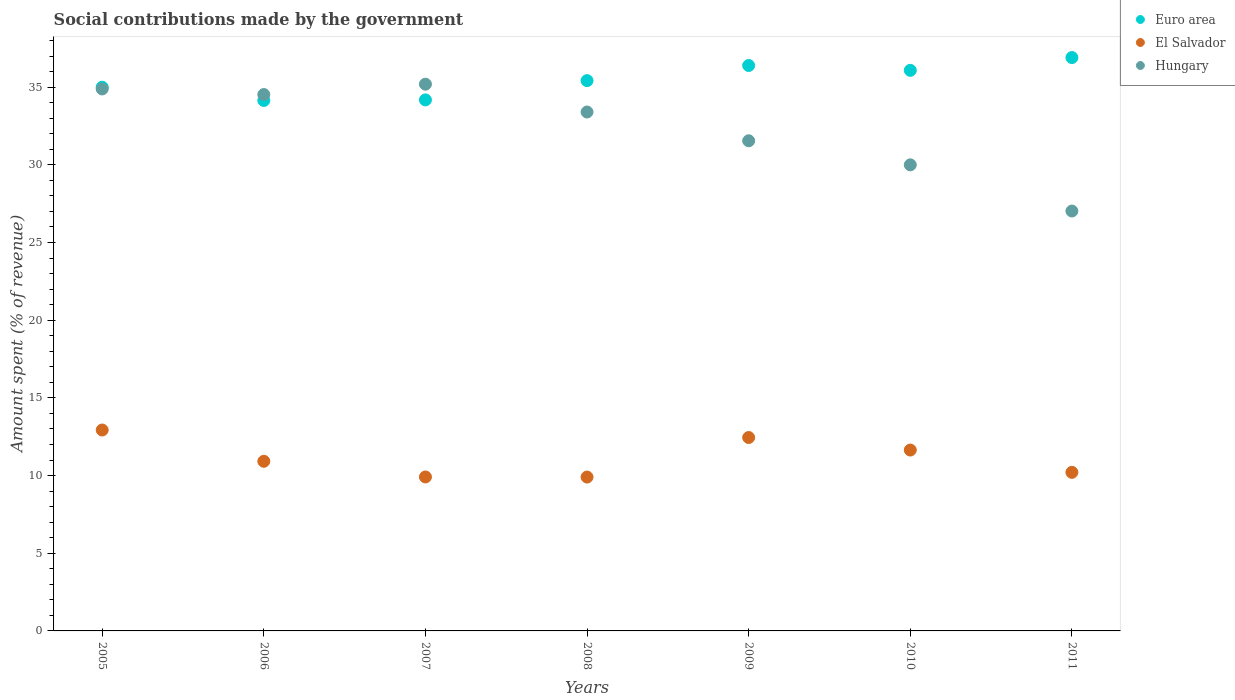What is the amount spent (in %) on social contributions in Hungary in 2007?
Ensure brevity in your answer.  35.19. Across all years, what is the maximum amount spent (in %) on social contributions in Hungary?
Offer a terse response. 35.19. Across all years, what is the minimum amount spent (in %) on social contributions in Hungary?
Ensure brevity in your answer.  27.03. In which year was the amount spent (in %) on social contributions in Euro area minimum?
Give a very brief answer. 2006. What is the total amount spent (in %) on social contributions in El Salvador in the graph?
Your answer should be compact. 77.96. What is the difference between the amount spent (in %) on social contributions in Hungary in 2008 and that in 2009?
Offer a terse response. 1.85. What is the difference between the amount spent (in %) on social contributions in El Salvador in 2005 and the amount spent (in %) on social contributions in Euro area in 2007?
Provide a short and direct response. -21.25. What is the average amount spent (in %) on social contributions in Euro area per year?
Ensure brevity in your answer.  35.44. In the year 2007, what is the difference between the amount spent (in %) on social contributions in Hungary and amount spent (in %) on social contributions in El Salvador?
Offer a very short reply. 25.28. In how many years, is the amount spent (in %) on social contributions in Hungary greater than 34 %?
Ensure brevity in your answer.  3. What is the ratio of the amount spent (in %) on social contributions in Euro area in 2007 to that in 2009?
Your answer should be compact. 0.94. Is the amount spent (in %) on social contributions in Euro area in 2005 less than that in 2006?
Give a very brief answer. No. Is the difference between the amount spent (in %) on social contributions in Hungary in 2007 and 2011 greater than the difference between the amount spent (in %) on social contributions in El Salvador in 2007 and 2011?
Offer a very short reply. Yes. What is the difference between the highest and the second highest amount spent (in %) on social contributions in El Salvador?
Offer a very short reply. 0.48. What is the difference between the highest and the lowest amount spent (in %) on social contributions in Hungary?
Provide a succinct answer. 8.16. In how many years, is the amount spent (in %) on social contributions in Euro area greater than the average amount spent (in %) on social contributions in Euro area taken over all years?
Offer a terse response. 3. Is the amount spent (in %) on social contributions in Euro area strictly less than the amount spent (in %) on social contributions in El Salvador over the years?
Make the answer very short. No. Are the values on the major ticks of Y-axis written in scientific E-notation?
Keep it short and to the point. No. Does the graph contain any zero values?
Provide a short and direct response. No. How many legend labels are there?
Provide a succinct answer. 3. What is the title of the graph?
Give a very brief answer. Social contributions made by the government. What is the label or title of the Y-axis?
Keep it short and to the point. Amount spent (% of revenue). What is the Amount spent (% of revenue) in Euro area in 2005?
Provide a short and direct response. 35. What is the Amount spent (% of revenue) of El Salvador in 2005?
Give a very brief answer. 12.93. What is the Amount spent (% of revenue) of Hungary in 2005?
Keep it short and to the point. 34.88. What is the Amount spent (% of revenue) in Euro area in 2006?
Provide a succinct answer. 34.14. What is the Amount spent (% of revenue) of El Salvador in 2006?
Provide a succinct answer. 10.92. What is the Amount spent (% of revenue) of Hungary in 2006?
Your response must be concise. 34.52. What is the Amount spent (% of revenue) in Euro area in 2007?
Your answer should be very brief. 34.18. What is the Amount spent (% of revenue) of El Salvador in 2007?
Your answer should be compact. 9.91. What is the Amount spent (% of revenue) in Hungary in 2007?
Provide a short and direct response. 35.19. What is the Amount spent (% of revenue) in Euro area in 2008?
Provide a succinct answer. 35.42. What is the Amount spent (% of revenue) in El Salvador in 2008?
Provide a succinct answer. 9.9. What is the Amount spent (% of revenue) of Hungary in 2008?
Provide a short and direct response. 33.4. What is the Amount spent (% of revenue) in Euro area in 2009?
Offer a terse response. 36.39. What is the Amount spent (% of revenue) of El Salvador in 2009?
Your answer should be very brief. 12.45. What is the Amount spent (% of revenue) of Hungary in 2009?
Provide a succinct answer. 31.55. What is the Amount spent (% of revenue) in Euro area in 2010?
Keep it short and to the point. 36.08. What is the Amount spent (% of revenue) of El Salvador in 2010?
Your answer should be very brief. 11.64. What is the Amount spent (% of revenue) of Hungary in 2010?
Provide a succinct answer. 30. What is the Amount spent (% of revenue) in Euro area in 2011?
Provide a short and direct response. 36.9. What is the Amount spent (% of revenue) in El Salvador in 2011?
Your answer should be compact. 10.21. What is the Amount spent (% of revenue) of Hungary in 2011?
Your answer should be compact. 27.03. Across all years, what is the maximum Amount spent (% of revenue) of Euro area?
Make the answer very short. 36.9. Across all years, what is the maximum Amount spent (% of revenue) of El Salvador?
Keep it short and to the point. 12.93. Across all years, what is the maximum Amount spent (% of revenue) in Hungary?
Keep it short and to the point. 35.19. Across all years, what is the minimum Amount spent (% of revenue) in Euro area?
Give a very brief answer. 34.14. Across all years, what is the minimum Amount spent (% of revenue) in El Salvador?
Ensure brevity in your answer.  9.9. Across all years, what is the minimum Amount spent (% of revenue) in Hungary?
Provide a succinct answer. 27.03. What is the total Amount spent (% of revenue) of Euro area in the graph?
Your answer should be very brief. 248.11. What is the total Amount spent (% of revenue) in El Salvador in the graph?
Make the answer very short. 77.96. What is the total Amount spent (% of revenue) of Hungary in the graph?
Your answer should be compact. 226.57. What is the difference between the Amount spent (% of revenue) of Euro area in 2005 and that in 2006?
Provide a short and direct response. 0.85. What is the difference between the Amount spent (% of revenue) of El Salvador in 2005 and that in 2006?
Offer a terse response. 2.01. What is the difference between the Amount spent (% of revenue) in Hungary in 2005 and that in 2006?
Give a very brief answer. 0.36. What is the difference between the Amount spent (% of revenue) in Euro area in 2005 and that in 2007?
Offer a very short reply. 0.82. What is the difference between the Amount spent (% of revenue) in El Salvador in 2005 and that in 2007?
Your response must be concise. 3.02. What is the difference between the Amount spent (% of revenue) of Hungary in 2005 and that in 2007?
Make the answer very short. -0.31. What is the difference between the Amount spent (% of revenue) in Euro area in 2005 and that in 2008?
Your answer should be very brief. -0.42. What is the difference between the Amount spent (% of revenue) of El Salvador in 2005 and that in 2008?
Provide a succinct answer. 3.03. What is the difference between the Amount spent (% of revenue) in Hungary in 2005 and that in 2008?
Offer a terse response. 1.48. What is the difference between the Amount spent (% of revenue) of Euro area in 2005 and that in 2009?
Provide a succinct answer. -1.4. What is the difference between the Amount spent (% of revenue) of El Salvador in 2005 and that in 2009?
Keep it short and to the point. 0.48. What is the difference between the Amount spent (% of revenue) in Hungary in 2005 and that in 2009?
Your response must be concise. 3.34. What is the difference between the Amount spent (% of revenue) of Euro area in 2005 and that in 2010?
Offer a very short reply. -1.08. What is the difference between the Amount spent (% of revenue) in El Salvador in 2005 and that in 2010?
Ensure brevity in your answer.  1.29. What is the difference between the Amount spent (% of revenue) of Hungary in 2005 and that in 2010?
Give a very brief answer. 4.89. What is the difference between the Amount spent (% of revenue) of Euro area in 2005 and that in 2011?
Your answer should be compact. -1.91. What is the difference between the Amount spent (% of revenue) in El Salvador in 2005 and that in 2011?
Provide a succinct answer. 2.73. What is the difference between the Amount spent (% of revenue) in Hungary in 2005 and that in 2011?
Offer a very short reply. 7.86. What is the difference between the Amount spent (% of revenue) in Euro area in 2006 and that in 2007?
Ensure brevity in your answer.  -0.04. What is the difference between the Amount spent (% of revenue) of El Salvador in 2006 and that in 2007?
Keep it short and to the point. 1.01. What is the difference between the Amount spent (% of revenue) in Hungary in 2006 and that in 2007?
Make the answer very short. -0.67. What is the difference between the Amount spent (% of revenue) in Euro area in 2006 and that in 2008?
Make the answer very short. -1.28. What is the difference between the Amount spent (% of revenue) in El Salvador in 2006 and that in 2008?
Provide a short and direct response. 1.02. What is the difference between the Amount spent (% of revenue) of Hungary in 2006 and that in 2008?
Your answer should be very brief. 1.12. What is the difference between the Amount spent (% of revenue) of Euro area in 2006 and that in 2009?
Make the answer very short. -2.25. What is the difference between the Amount spent (% of revenue) in El Salvador in 2006 and that in 2009?
Your response must be concise. -1.53. What is the difference between the Amount spent (% of revenue) in Hungary in 2006 and that in 2009?
Provide a short and direct response. 2.98. What is the difference between the Amount spent (% of revenue) of Euro area in 2006 and that in 2010?
Make the answer very short. -1.94. What is the difference between the Amount spent (% of revenue) in El Salvador in 2006 and that in 2010?
Ensure brevity in your answer.  -0.72. What is the difference between the Amount spent (% of revenue) in Hungary in 2006 and that in 2010?
Offer a very short reply. 4.52. What is the difference between the Amount spent (% of revenue) of Euro area in 2006 and that in 2011?
Your answer should be very brief. -2.76. What is the difference between the Amount spent (% of revenue) in El Salvador in 2006 and that in 2011?
Provide a succinct answer. 0.71. What is the difference between the Amount spent (% of revenue) of Hungary in 2006 and that in 2011?
Give a very brief answer. 7.5. What is the difference between the Amount spent (% of revenue) of Euro area in 2007 and that in 2008?
Keep it short and to the point. -1.24. What is the difference between the Amount spent (% of revenue) of El Salvador in 2007 and that in 2008?
Keep it short and to the point. 0.01. What is the difference between the Amount spent (% of revenue) of Hungary in 2007 and that in 2008?
Ensure brevity in your answer.  1.79. What is the difference between the Amount spent (% of revenue) of Euro area in 2007 and that in 2009?
Provide a short and direct response. -2.21. What is the difference between the Amount spent (% of revenue) in El Salvador in 2007 and that in 2009?
Offer a terse response. -2.54. What is the difference between the Amount spent (% of revenue) in Hungary in 2007 and that in 2009?
Your answer should be very brief. 3.64. What is the difference between the Amount spent (% of revenue) of Euro area in 2007 and that in 2010?
Your answer should be compact. -1.9. What is the difference between the Amount spent (% of revenue) of El Salvador in 2007 and that in 2010?
Keep it short and to the point. -1.73. What is the difference between the Amount spent (% of revenue) in Hungary in 2007 and that in 2010?
Give a very brief answer. 5.19. What is the difference between the Amount spent (% of revenue) of Euro area in 2007 and that in 2011?
Offer a terse response. -2.73. What is the difference between the Amount spent (% of revenue) in El Salvador in 2007 and that in 2011?
Provide a short and direct response. -0.3. What is the difference between the Amount spent (% of revenue) in Hungary in 2007 and that in 2011?
Make the answer very short. 8.16. What is the difference between the Amount spent (% of revenue) of Euro area in 2008 and that in 2009?
Make the answer very short. -0.97. What is the difference between the Amount spent (% of revenue) in El Salvador in 2008 and that in 2009?
Offer a very short reply. -2.54. What is the difference between the Amount spent (% of revenue) in Hungary in 2008 and that in 2009?
Offer a terse response. 1.85. What is the difference between the Amount spent (% of revenue) of Euro area in 2008 and that in 2010?
Offer a very short reply. -0.66. What is the difference between the Amount spent (% of revenue) in El Salvador in 2008 and that in 2010?
Give a very brief answer. -1.74. What is the difference between the Amount spent (% of revenue) in Hungary in 2008 and that in 2010?
Offer a very short reply. 3.4. What is the difference between the Amount spent (% of revenue) in Euro area in 2008 and that in 2011?
Your answer should be very brief. -1.48. What is the difference between the Amount spent (% of revenue) in El Salvador in 2008 and that in 2011?
Your answer should be compact. -0.3. What is the difference between the Amount spent (% of revenue) of Hungary in 2008 and that in 2011?
Ensure brevity in your answer.  6.37. What is the difference between the Amount spent (% of revenue) of Euro area in 2009 and that in 2010?
Your answer should be very brief. 0.31. What is the difference between the Amount spent (% of revenue) of El Salvador in 2009 and that in 2010?
Make the answer very short. 0.81. What is the difference between the Amount spent (% of revenue) of Hungary in 2009 and that in 2010?
Make the answer very short. 1.55. What is the difference between the Amount spent (% of revenue) of Euro area in 2009 and that in 2011?
Ensure brevity in your answer.  -0.51. What is the difference between the Amount spent (% of revenue) of El Salvador in 2009 and that in 2011?
Your response must be concise. 2.24. What is the difference between the Amount spent (% of revenue) of Hungary in 2009 and that in 2011?
Ensure brevity in your answer.  4.52. What is the difference between the Amount spent (% of revenue) in Euro area in 2010 and that in 2011?
Ensure brevity in your answer.  -0.82. What is the difference between the Amount spent (% of revenue) of El Salvador in 2010 and that in 2011?
Offer a very short reply. 1.44. What is the difference between the Amount spent (% of revenue) of Hungary in 2010 and that in 2011?
Keep it short and to the point. 2.97. What is the difference between the Amount spent (% of revenue) of Euro area in 2005 and the Amount spent (% of revenue) of El Salvador in 2006?
Give a very brief answer. 24.08. What is the difference between the Amount spent (% of revenue) in Euro area in 2005 and the Amount spent (% of revenue) in Hungary in 2006?
Offer a terse response. 0.47. What is the difference between the Amount spent (% of revenue) in El Salvador in 2005 and the Amount spent (% of revenue) in Hungary in 2006?
Make the answer very short. -21.59. What is the difference between the Amount spent (% of revenue) in Euro area in 2005 and the Amount spent (% of revenue) in El Salvador in 2007?
Your answer should be very brief. 25.09. What is the difference between the Amount spent (% of revenue) in Euro area in 2005 and the Amount spent (% of revenue) in Hungary in 2007?
Offer a terse response. -0.19. What is the difference between the Amount spent (% of revenue) of El Salvador in 2005 and the Amount spent (% of revenue) of Hungary in 2007?
Offer a terse response. -22.26. What is the difference between the Amount spent (% of revenue) in Euro area in 2005 and the Amount spent (% of revenue) in El Salvador in 2008?
Offer a very short reply. 25.09. What is the difference between the Amount spent (% of revenue) of Euro area in 2005 and the Amount spent (% of revenue) of Hungary in 2008?
Provide a succinct answer. 1.6. What is the difference between the Amount spent (% of revenue) of El Salvador in 2005 and the Amount spent (% of revenue) of Hungary in 2008?
Provide a succinct answer. -20.47. What is the difference between the Amount spent (% of revenue) of Euro area in 2005 and the Amount spent (% of revenue) of El Salvador in 2009?
Keep it short and to the point. 22.55. What is the difference between the Amount spent (% of revenue) of Euro area in 2005 and the Amount spent (% of revenue) of Hungary in 2009?
Offer a very short reply. 3.45. What is the difference between the Amount spent (% of revenue) in El Salvador in 2005 and the Amount spent (% of revenue) in Hungary in 2009?
Make the answer very short. -18.62. What is the difference between the Amount spent (% of revenue) of Euro area in 2005 and the Amount spent (% of revenue) of El Salvador in 2010?
Your response must be concise. 23.35. What is the difference between the Amount spent (% of revenue) in Euro area in 2005 and the Amount spent (% of revenue) in Hungary in 2010?
Offer a terse response. 5. What is the difference between the Amount spent (% of revenue) in El Salvador in 2005 and the Amount spent (% of revenue) in Hungary in 2010?
Offer a terse response. -17.07. What is the difference between the Amount spent (% of revenue) in Euro area in 2005 and the Amount spent (% of revenue) in El Salvador in 2011?
Your answer should be compact. 24.79. What is the difference between the Amount spent (% of revenue) of Euro area in 2005 and the Amount spent (% of revenue) of Hungary in 2011?
Make the answer very short. 7.97. What is the difference between the Amount spent (% of revenue) in El Salvador in 2005 and the Amount spent (% of revenue) in Hungary in 2011?
Keep it short and to the point. -14.09. What is the difference between the Amount spent (% of revenue) in Euro area in 2006 and the Amount spent (% of revenue) in El Salvador in 2007?
Ensure brevity in your answer.  24.23. What is the difference between the Amount spent (% of revenue) in Euro area in 2006 and the Amount spent (% of revenue) in Hungary in 2007?
Provide a short and direct response. -1.05. What is the difference between the Amount spent (% of revenue) of El Salvador in 2006 and the Amount spent (% of revenue) of Hungary in 2007?
Provide a succinct answer. -24.27. What is the difference between the Amount spent (% of revenue) of Euro area in 2006 and the Amount spent (% of revenue) of El Salvador in 2008?
Ensure brevity in your answer.  24.24. What is the difference between the Amount spent (% of revenue) of Euro area in 2006 and the Amount spent (% of revenue) of Hungary in 2008?
Keep it short and to the point. 0.74. What is the difference between the Amount spent (% of revenue) of El Salvador in 2006 and the Amount spent (% of revenue) of Hungary in 2008?
Your response must be concise. -22.48. What is the difference between the Amount spent (% of revenue) of Euro area in 2006 and the Amount spent (% of revenue) of El Salvador in 2009?
Your response must be concise. 21.69. What is the difference between the Amount spent (% of revenue) of Euro area in 2006 and the Amount spent (% of revenue) of Hungary in 2009?
Provide a short and direct response. 2.59. What is the difference between the Amount spent (% of revenue) in El Salvador in 2006 and the Amount spent (% of revenue) in Hungary in 2009?
Ensure brevity in your answer.  -20.63. What is the difference between the Amount spent (% of revenue) of Euro area in 2006 and the Amount spent (% of revenue) of El Salvador in 2010?
Your response must be concise. 22.5. What is the difference between the Amount spent (% of revenue) in Euro area in 2006 and the Amount spent (% of revenue) in Hungary in 2010?
Give a very brief answer. 4.14. What is the difference between the Amount spent (% of revenue) of El Salvador in 2006 and the Amount spent (% of revenue) of Hungary in 2010?
Your response must be concise. -19.08. What is the difference between the Amount spent (% of revenue) of Euro area in 2006 and the Amount spent (% of revenue) of El Salvador in 2011?
Provide a short and direct response. 23.94. What is the difference between the Amount spent (% of revenue) of Euro area in 2006 and the Amount spent (% of revenue) of Hungary in 2011?
Your response must be concise. 7.12. What is the difference between the Amount spent (% of revenue) of El Salvador in 2006 and the Amount spent (% of revenue) of Hungary in 2011?
Provide a succinct answer. -16.11. What is the difference between the Amount spent (% of revenue) of Euro area in 2007 and the Amount spent (% of revenue) of El Salvador in 2008?
Your answer should be compact. 24.27. What is the difference between the Amount spent (% of revenue) of Euro area in 2007 and the Amount spent (% of revenue) of Hungary in 2008?
Provide a short and direct response. 0.78. What is the difference between the Amount spent (% of revenue) in El Salvador in 2007 and the Amount spent (% of revenue) in Hungary in 2008?
Make the answer very short. -23.49. What is the difference between the Amount spent (% of revenue) of Euro area in 2007 and the Amount spent (% of revenue) of El Salvador in 2009?
Keep it short and to the point. 21.73. What is the difference between the Amount spent (% of revenue) of Euro area in 2007 and the Amount spent (% of revenue) of Hungary in 2009?
Offer a terse response. 2.63. What is the difference between the Amount spent (% of revenue) in El Salvador in 2007 and the Amount spent (% of revenue) in Hungary in 2009?
Give a very brief answer. -21.64. What is the difference between the Amount spent (% of revenue) in Euro area in 2007 and the Amount spent (% of revenue) in El Salvador in 2010?
Offer a terse response. 22.54. What is the difference between the Amount spent (% of revenue) of Euro area in 2007 and the Amount spent (% of revenue) of Hungary in 2010?
Your answer should be compact. 4.18. What is the difference between the Amount spent (% of revenue) in El Salvador in 2007 and the Amount spent (% of revenue) in Hungary in 2010?
Ensure brevity in your answer.  -20.09. What is the difference between the Amount spent (% of revenue) in Euro area in 2007 and the Amount spent (% of revenue) in El Salvador in 2011?
Your response must be concise. 23.97. What is the difference between the Amount spent (% of revenue) in Euro area in 2007 and the Amount spent (% of revenue) in Hungary in 2011?
Your answer should be very brief. 7.15. What is the difference between the Amount spent (% of revenue) in El Salvador in 2007 and the Amount spent (% of revenue) in Hungary in 2011?
Make the answer very short. -17.12. What is the difference between the Amount spent (% of revenue) in Euro area in 2008 and the Amount spent (% of revenue) in El Salvador in 2009?
Keep it short and to the point. 22.97. What is the difference between the Amount spent (% of revenue) in Euro area in 2008 and the Amount spent (% of revenue) in Hungary in 2009?
Your answer should be very brief. 3.87. What is the difference between the Amount spent (% of revenue) in El Salvador in 2008 and the Amount spent (% of revenue) in Hungary in 2009?
Provide a short and direct response. -21.64. What is the difference between the Amount spent (% of revenue) of Euro area in 2008 and the Amount spent (% of revenue) of El Salvador in 2010?
Ensure brevity in your answer.  23.78. What is the difference between the Amount spent (% of revenue) of Euro area in 2008 and the Amount spent (% of revenue) of Hungary in 2010?
Make the answer very short. 5.42. What is the difference between the Amount spent (% of revenue) of El Salvador in 2008 and the Amount spent (% of revenue) of Hungary in 2010?
Keep it short and to the point. -20.1. What is the difference between the Amount spent (% of revenue) of Euro area in 2008 and the Amount spent (% of revenue) of El Salvador in 2011?
Provide a short and direct response. 25.21. What is the difference between the Amount spent (% of revenue) in Euro area in 2008 and the Amount spent (% of revenue) in Hungary in 2011?
Your response must be concise. 8.39. What is the difference between the Amount spent (% of revenue) in El Salvador in 2008 and the Amount spent (% of revenue) in Hungary in 2011?
Provide a succinct answer. -17.12. What is the difference between the Amount spent (% of revenue) of Euro area in 2009 and the Amount spent (% of revenue) of El Salvador in 2010?
Offer a terse response. 24.75. What is the difference between the Amount spent (% of revenue) in Euro area in 2009 and the Amount spent (% of revenue) in Hungary in 2010?
Offer a terse response. 6.39. What is the difference between the Amount spent (% of revenue) in El Salvador in 2009 and the Amount spent (% of revenue) in Hungary in 2010?
Keep it short and to the point. -17.55. What is the difference between the Amount spent (% of revenue) of Euro area in 2009 and the Amount spent (% of revenue) of El Salvador in 2011?
Give a very brief answer. 26.19. What is the difference between the Amount spent (% of revenue) of Euro area in 2009 and the Amount spent (% of revenue) of Hungary in 2011?
Make the answer very short. 9.37. What is the difference between the Amount spent (% of revenue) in El Salvador in 2009 and the Amount spent (% of revenue) in Hungary in 2011?
Give a very brief answer. -14.58. What is the difference between the Amount spent (% of revenue) of Euro area in 2010 and the Amount spent (% of revenue) of El Salvador in 2011?
Your answer should be compact. 25.87. What is the difference between the Amount spent (% of revenue) in Euro area in 2010 and the Amount spent (% of revenue) in Hungary in 2011?
Ensure brevity in your answer.  9.05. What is the difference between the Amount spent (% of revenue) in El Salvador in 2010 and the Amount spent (% of revenue) in Hungary in 2011?
Your answer should be compact. -15.38. What is the average Amount spent (% of revenue) of Euro area per year?
Your answer should be very brief. 35.44. What is the average Amount spent (% of revenue) of El Salvador per year?
Make the answer very short. 11.14. What is the average Amount spent (% of revenue) of Hungary per year?
Provide a short and direct response. 32.37. In the year 2005, what is the difference between the Amount spent (% of revenue) in Euro area and Amount spent (% of revenue) in El Salvador?
Keep it short and to the point. 22.06. In the year 2005, what is the difference between the Amount spent (% of revenue) of Euro area and Amount spent (% of revenue) of Hungary?
Provide a short and direct response. 0.11. In the year 2005, what is the difference between the Amount spent (% of revenue) in El Salvador and Amount spent (% of revenue) in Hungary?
Ensure brevity in your answer.  -21.95. In the year 2006, what is the difference between the Amount spent (% of revenue) of Euro area and Amount spent (% of revenue) of El Salvador?
Your response must be concise. 23.22. In the year 2006, what is the difference between the Amount spent (% of revenue) in Euro area and Amount spent (% of revenue) in Hungary?
Your answer should be very brief. -0.38. In the year 2006, what is the difference between the Amount spent (% of revenue) in El Salvador and Amount spent (% of revenue) in Hungary?
Provide a short and direct response. -23.6. In the year 2007, what is the difference between the Amount spent (% of revenue) in Euro area and Amount spent (% of revenue) in El Salvador?
Provide a succinct answer. 24.27. In the year 2007, what is the difference between the Amount spent (% of revenue) of Euro area and Amount spent (% of revenue) of Hungary?
Provide a short and direct response. -1.01. In the year 2007, what is the difference between the Amount spent (% of revenue) in El Salvador and Amount spent (% of revenue) in Hungary?
Your answer should be compact. -25.28. In the year 2008, what is the difference between the Amount spent (% of revenue) in Euro area and Amount spent (% of revenue) in El Salvador?
Your response must be concise. 25.52. In the year 2008, what is the difference between the Amount spent (% of revenue) in Euro area and Amount spent (% of revenue) in Hungary?
Provide a short and direct response. 2.02. In the year 2008, what is the difference between the Amount spent (% of revenue) of El Salvador and Amount spent (% of revenue) of Hungary?
Your answer should be very brief. -23.5. In the year 2009, what is the difference between the Amount spent (% of revenue) of Euro area and Amount spent (% of revenue) of El Salvador?
Your response must be concise. 23.94. In the year 2009, what is the difference between the Amount spent (% of revenue) of Euro area and Amount spent (% of revenue) of Hungary?
Ensure brevity in your answer.  4.85. In the year 2009, what is the difference between the Amount spent (% of revenue) in El Salvador and Amount spent (% of revenue) in Hungary?
Offer a very short reply. -19.1. In the year 2010, what is the difference between the Amount spent (% of revenue) in Euro area and Amount spent (% of revenue) in El Salvador?
Your response must be concise. 24.44. In the year 2010, what is the difference between the Amount spent (% of revenue) of Euro area and Amount spent (% of revenue) of Hungary?
Your response must be concise. 6.08. In the year 2010, what is the difference between the Amount spent (% of revenue) in El Salvador and Amount spent (% of revenue) in Hungary?
Your answer should be very brief. -18.36. In the year 2011, what is the difference between the Amount spent (% of revenue) of Euro area and Amount spent (% of revenue) of El Salvador?
Make the answer very short. 26.7. In the year 2011, what is the difference between the Amount spent (% of revenue) in Euro area and Amount spent (% of revenue) in Hungary?
Ensure brevity in your answer.  9.88. In the year 2011, what is the difference between the Amount spent (% of revenue) in El Salvador and Amount spent (% of revenue) in Hungary?
Your answer should be very brief. -16.82. What is the ratio of the Amount spent (% of revenue) of El Salvador in 2005 to that in 2006?
Your answer should be compact. 1.18. What is the ratio of the Amount spent (% of revenue) of Hungary in 2005 to that in 2006?
Keep it short and to the point. 1.01. What is the ratio of the Amount spent (% of revenue) of El Salvador in 2005 to that in 2007?
Provide a short and direct response. 1.3. What is the ratio of the Amount spent (% of revenue) in El Salvador in 2005 to that in 2008?
Your answer should be compact. 1.31. What is the ratio of the Amount spent (% of revenue) in Hungary in 2005 to that in 2008?
Give a very brief answer. 1.04. What is the ratio of the Amount spent (% of revenue) in Euro area in 2005 to that in 2009?
Your answer should be compact. 0.96. What is the ratio of the Amount spent (% of revenue) of El Salvador in 2005 to that in 2009?
Keep it short and to the point. 1.04. What is the ratio of the Amount spent (% of revenue) of Hungary in 2005 to that in 2009?
Make the answer very short. 1.11. What is the ratio of the Amount spent (% of revenue) of Euro area in 2005 to that in 2010?
Keep it short and to the point. 0.97. What is the ratio of the Amount spent (% of revenue) in El Salvador in 2005 to that in 2010?
Offer a terse response. 1.11. What is the ratio of the Amount spent (% of revenue) of Hungary in 2005 to that in 2010?
Offer a very short reply. 1.16. What is the ratio of the Amount spent (% of revenue) in Euro area in 2005 to that in 2011?
Ensure brevity in your answer.  0.95. What is the ratio of the Amount spent (% of revenue) in El Salvador in 2005 to that in 2011?
Your response must be concise. 1.27. What is the ratio of the Amount spent (% of revenue) of Hungary in 2005 to that in 2011?
Make the answer very short. 1.29. What is the ratio of the Amount spent (% of revenue) in Euro area in 2006 to that in 2007?
Your response must be concise. 1. What is the ratio of the Amount spent (% of revenue) of El Salvador in 2006 to that in 2007?
Offer a very short reply. 1.1. What is the ratio of the Amount spent (% of revenue) in Hungary in 2006 to that in 2007?
Make the answer very short. 0.98. What is the ratio of the Amount spent (% of revenue) in Euro area in 2006 to that in 2008?
Your response must be concise. 0.96. What is the ratio of the Amount spent (% of revenue) in El Salvador in 2006 to that in 2008?
Your answer should be very brief. 1.1. What is the ratio of the Amount spent (% of revenue) in Hungary in 2006 to that in 2008?
Offer a very short reply. 1.03. What is the ratio of the Amount spent (% of revenue) in Euro area in 2006 to that in 2009?
Provide a succinct answer. 0.94. What is the ratio of the Amount spent (% of revenue) of El Salvador in 2006 to that in 2009?
Ensure brevity in your answer.  0.88. What is the ratio of the Amount spent (% of revenue) of Hungary in 2006 to that in 2009?
Offer a very short reply. 1.09. What is the ratio of the Amount spent (% of revenue) in Euro area in 2006 to that in 2010?
Your answer should be compact. 0.95. What is the ratio of the Amount spent (% of revenue) of El Salvador in 2006 to that in 2010?
Provide a short and direct response. 0.94. What is the ratio of the Amount spent (% of revenue) of Hungary in 2006 to that in 2010?
Keep it short and to the point. 1.15. What is the ratio of the Amount spent (% of revenue) in Euro area in 2006 to that in 2011?
Your answer should be very brief. 0.93. What is the ratio of the Amount spent (% of revenue) in El Salvador in 2006 to that in 2011?
Ensure brevity in your answer.  1.07. What is the ratio of the Amount spent (% of revenue) of Hungary in 2006 to that in 2011?
Give a very brief answer. 1.28. What is the ratio of the Amount spent (% of revenue) of Euro area in 2007 to that in 2008?
Your answer should be very brief. 0.96. What is the ratio of the Amount spent (% of revenue) of El Salvador in 2007 to that in 2008?
Provide a succinct answer. 1. What is the ratio of the Amount spent (% of revenue) in Hungary in 2007 to that in 2008?
Ensure brevity in your answer.  1.05. What is the ratio of the Amount spent (% of revenue) of Euro area in 2007 to that in 2009?
Your answer should be very brief. 0.94. What is the ratio of the Amount spent (% of revenue) of El Salvador in 2007 to that in 2009?
Offer a very short reply. 0.8. What is the ratio of the Amount spent (% of revenue) in Hungary in 2007 to that in 2009?
Give a very brief answer. 1.12. What is the ratio of the Amount spent (% of revenue) of Euro area in 2007 to that in 2010?
Make the answer very short. 0.95. What is the ratio of the Amount spent (% of revenue) of El Salvador in 2007 to that in 2010?
Offer a terse response. 0.85. What is the ratio of the Amount spent (% of revenue) in Hungary in 2007 to that in 2010?
Provide a succinct answer. 1.17. What is the ratio of the Amount spent (% of revenue) of Euro area in 2007 to that in 2011?
Your response must be concise. 0.93. What is the ratio of the Amount spent (% of revenue) in El Salvador in 2007 to that in 2011?
Keep it short and to the point. 0.97. What is the ratio of the Amount spent (% of revenue) of Hungary in 2007 to that in 2011?
Make the answer very short. 1.3. What is the ratio of the Amount spent (% of revenue) in Euro area in 2008 to that in 2009?
Provide a short and direct response. 0.97. What is the ratio of the Amount spent (% of revenue) of El Salvador in 2008 to that in 2009?
Offer a terse response. 0.8. What is the ratio of the Amount spent (% of revenue) in Hungary in 2008 to that in 2009?
Offer a very short reply. 1.06. What is the ratio of the Amount spent (% of revenue) in Euro area in 2008 to that in 2010?
Your answer should be compact. 0.98. What is the ratio of the Amount spent (% of revenue) in El Salvador in 2008 to that in 2010?
Your answer should be compact. 0.85. What is the ratio of the Amount spent (% of revenue) of Hungary in 2008 to that in 2010?
Offer a terse response. 1.11. What is the ratio of the Amount spent (% of revenue) in Euro area in 2008 to that in 2011?
Provide a succinct answer. 0.96. What is the ratio of the Amount spent (% of revenue) in El Salvador in 2008 to that in 2011?
Your response must be concise. 0.97. What is the ratio of the Amount spent (% of revenue) of Hungary in 2008 to that in 2011?
Your response must be concise. 1.24. What is the ratio of the Amount spent (% of revenue) in Euro area in 2009 to that in 2010?
Your answer should be very brief. 1.01. What is the ratio of the Amount spent (% of revenue) in El Salvador in 2009 to that in 2010?
Offer a terse response. 1.07. What is the ratio of the Amount spent (% of revenue) of Hungary in 2009 to that in 2010?
Your answer should be very brief. 1.05. What is the ratio of the Amount spent (% of revenue) in Euro area in 2009 to that in 2011?
Your response must be concise. 0.99. What is the ratio of the Amount spent (% of revenue) of El Salvador in 2009 to that in 2011?
Your answer should be very brief. 1.22. What is the ratio of the Amount spent (% of revenue) of Hungary in 2009 to that in 2011?
Make the answer very short. 1.17. What is the ratio of the Amount spent (% of revenue) of Euro area in 2010 to that in 2011?
Offer a terse response. 0.98. What is the ratio of the Amount spent (% of revenue) in El Salvador in 2010 to that in 2011?
Your answer should be very brief. 1.14. What is the ratio of the Amount spent (% of revenue) in Hungary in 2010 to that in 2011?
Keep it short and to the point. 1.11. What is the difference between the highest and the second highest Amount spent (% of revenue) in Euro area?
Make the answer very short. 0.51. What is the difference between the highest and the second highest Amount spent (% of revenue) in El Salvador?
Offer a very short reply. 0.48. What is the difference between the highest and the second highest Amount spent (% of revenue) of Hungary?
Give a very brief answer. 0.31. What is the difference between the highest and the lowest Amount spent (% of revenue) in Euro area?
Your response must be concise. 2.76. What is the difference between the highest and the lowest Amount spent (% of revenue) of El Salvador?
Ensure brevity in your answer.  3.03. What is the difference between the highest and the lowest Amount spent (% of revenue) of Hungary?
Your response must be concise. 8.16. 